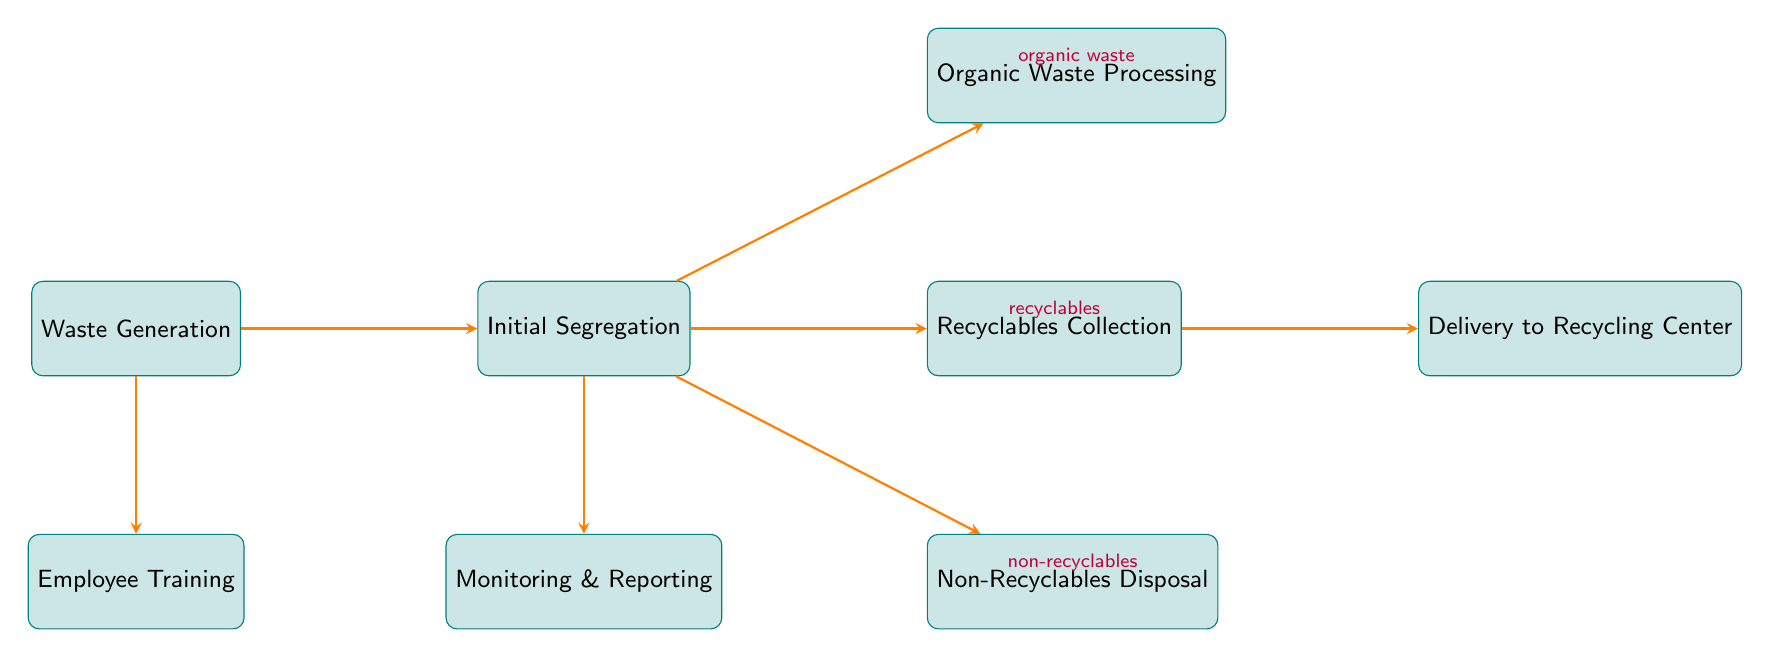What is the first step in the waste management workflow? The flowchart begins with "Waste Generation," which is the first node listed. This is the initial step of the waste management process before any segregation or processing occurs.
Answer: Waste Generation How many types of waste are separated during Initial Segregation? In the diagram, Initial Segregation separates waste into three types: organic waste, recyclables, and non-recyclables. Hence, there are three categories mentioned.
Answer: Three What is done with organic waste after Initial Segregation? According to the diagram, organic waste is processed next, specifically through either composting or sending to a bio-digester after it has been segregated.
Answer: Organic Waste Processing What happens to recyclables after collection? The flowchart indicates that after recyclables are collected, they are delivered to a recycling center for processing, which means that transport occurs next.
Answer: Delivery to Recycling Center Which node connects Waste Generation directly to Employee Training? The diagram shows a direct arrow from Waste Generation to Employee Training, indicating that employee training is informed by the waste generated.
Answer: Waste Generation What is the main purpose of Monitoring & Reporting? The flowchart shows that Monitoring & Reporting is focused on tracking and analyzing waste output, which implies its purpose is to ensure the waste management process is working effectively and is reported to management.
Answer: Track and analyze waste output What condition leads to Non-Recyclables Disposal? The diagram states that the condition leading to Non-Recyclables Disposal is identified when waste is classified as non-recyclable during the Initial Segregation step.
Answer: Non-recyclables How many nodes are part of the Waste Management Workflow for Restaurants? The diagram includes eight distinct nodes that represent different steps and activities within the waste management workflow.
Answer: Eight What role does Employee Training play in the flowchart? Employee Training is depicted as a crucial part of the process that comes directly from Waste Generation, emphasizing the need for staff to understand waste segregation and reduction techniques.
Answer: Regular training on waste segregation and reduction 